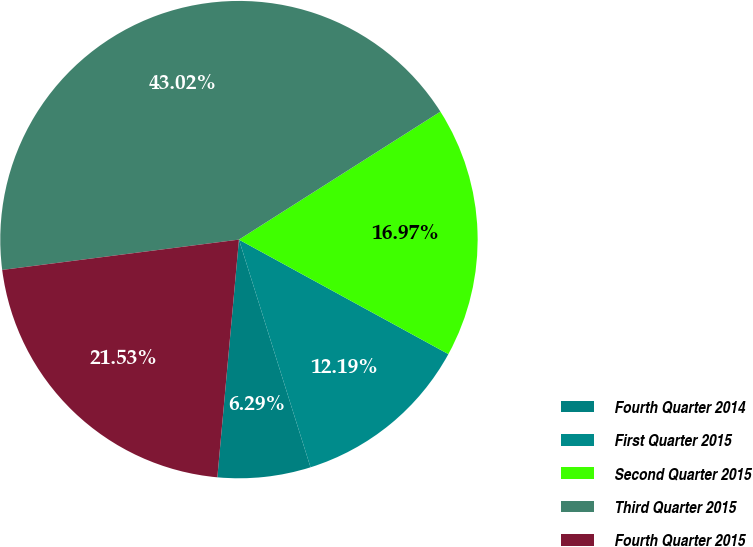Convert chart to OTSL. <chart><loc_0><loc_0><loc_500><loc_500><pie_chart><fcel>Fourth Quarter 2014<fcel>First Quarter 2015<fcel>Second Quarter 2015<fcel>Third Quarter 2015<fcel>Fourth Quarter 2015<nl><fcel>6.29%<fcel>12.19%<fcel>16.97%<fcel>43.02%<fcel>21.53%<nl></chart> 